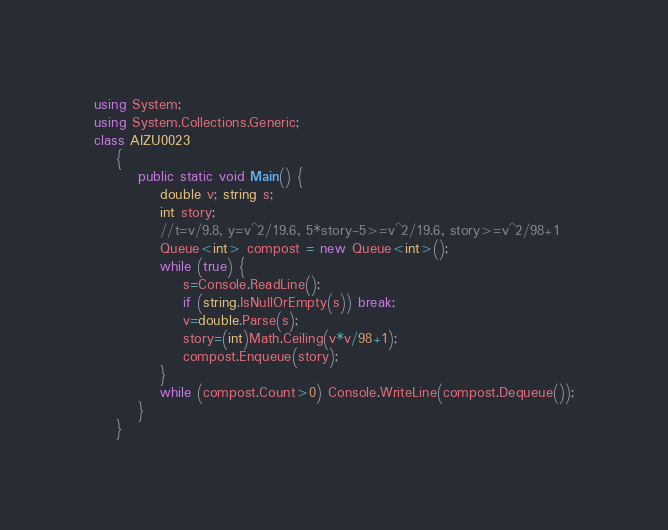Convert code to text. <code><loc_0><loc_0><loc_500><loc_500><_C#_>using System;
using System.Collections.Generic;
class AIZU0023
    {
        public static void Main() {
            double v; string s;
            int story;
            //t=v/9.8, y=v^2/19.6, 5*story-5>=v^2/19.6, story>=v^2/98+1
            Queue<int> compost = new Queue<int>();
            while (true) {
                s=Console.ReadLine();
                if (string.IsNullOrEmpty(s)) break;
                v=double.Parse(s);
                story=(int)Math.Ceiling(v*v/98+1);
                compost.Enqueue(story);
            }
            while (compost.Count>0) Console.WriteLine(compost.Dequeue());
        }
    }</code> 